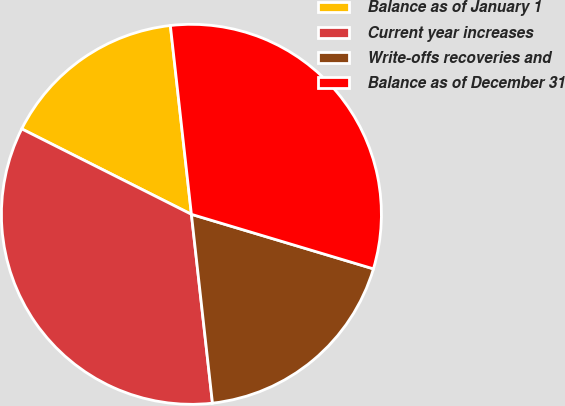<chart> <loc_0><loc_0><loc_500><loc_500><pie_chart><fcel>Balance as of January 1<fcel>Current year increases<fcel>Write-offs recoveries and<fcel>Balance as of December 31<nl><fcel>15.81%<fcel>34.19%<fcel>18.6%<fcel>31.4%<nl></chart> 